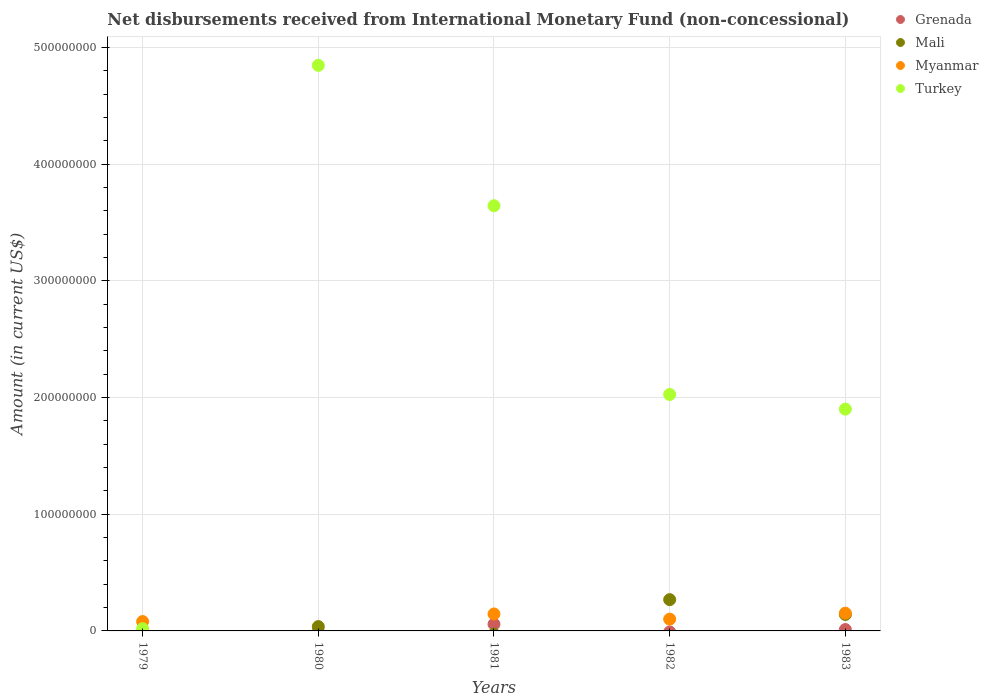What is the amount of disbursements received from International Monetary Fund in Myanmar in 1981?
Ensure brevity in your answer.  1.45e+07. Across all years, what is the maximum amount of disbursements received from International Monetary Fund in Grenada?
Your answer should be very brief. 5.80e+06. Across all years, what is the minimum amount of disbursements received from International Monetary Fund in Mali?
Provide a short and direct response. 0. In which year was the amount of disbursements received from International Monetary Fund in Turkey maximum?
Provide a short and direct response. 1980. What is the total amount of disbursements received from International Monetary Fund in Grenada in the graph?
Your answer should be very brief. 6.98e+06. What is the difference between the amount of disbursements received from International Monetary Fund in Mali in 1982 and that in 1983?
Give a very brief answer. 1.27e+07. What is the difference between the amount of disbursements received from International Monetary Fund in Grenada in 1979 and the amount of disbursements received from International Monetary Fund in Turkey in 1981?
Provide a short and direct response. -3.64e+08. What is the average amount of disbursements received from International Monetary Fund in Mali per year?
Your response must be concise. 8.92e+06. In the year 1982, what is the difference between the amount of disbursements received from International Monetary Fund in Mali and amount of disbursements received from International Monetary Fund in Myanmar?
Your response must be concise. 1.67e+07. In how many years, is the amount of disbursements received from International Monetary Fund in Grenada greater than 100000000 US$?
Your answer should be compact. 0. What is the ratio of the amount of disbursements received from International Monetary Fund in Myanmar in 1979 to that in 1982?
Offer a terse response. 0.8. Is the amount of disbursements received from International Monetary Fund in Myanmar in 1981 less than that in 1983?
Ensure brevity in your answer.  Yes. What is the difference between the highest and the second highest amount of disbursements received from International Monetary Fund in Turkey?
Your response must be concise. 1.20e+08. What is the difference between the highest and the lowest amount of disbursements received from International Monetary Fund in Mali?
Your answer should be very brief. 2.68e+07. In how many years, is the amount of disbursements received from International Monetary Fund in Grenada greater than the average amount of disbursements received from International Monetary Fund in Grenada taken over all years?
Offer a very short reply. 1. Is the sum of the amount of disbursements received from International Monetary Fund in Mali in 1980 and 1983 greater than the maximum amount of disbursements received from International Monetary Fund in Turkey across all years?
Give a very brief answer. No. Is it the case that in every year, the sum of the amount of disbursements received from International Monetary Fund in Mali and amount of disbursements received from International Monetary Fund in Turkey  is greater than the amount of disbursements received from International Monetary Fund in Myanmar?
Provide a succinct answer. No. Does the amount of disbursements received from International Monetary Fund in Grenada monotonically increase over the years?
Ensure brevity in your answer.  No. Is the amount of disbursements received from International Monetary Fund in Mali strictly greater than the amount of disbursements received from International Monetary Fund in Turkey over the years?
Your answer should be very brief. No. Is the amount of disbursements received from International Monetary Fund in Turkey strictly less than the amount of disbursements received from International Monetary Fund in Myanmar over the years?
Provide a succinct answer. No. How many years are there in the graph?
Your answer should be compact. 5. Does the graph contain grids?
Offer a very short reply. Yes. Where does the legend appear in the graph?
Ensure brevity in your answer.  Top right. How many legend labels are there?
Provide a succinct answer. 4. What is the title of the graph?
Ensure brevity in your answer.  Net disbursements received from International Monetary Fund (non-concessional). Does "Isle of Man" appear as one of the legend labels in the graph?
Provide a succinct answer. No. What is the Amount (in current US$) of Mali in 1979?
Provide a short and direct response. 0. What is the Amount (in current US$) of Myanmar in 1979?
Keep it short and to the point. 8.03e+06. What is the Amount (in current US$) of Turkey in 1979?
Your answer should be compact. 1.91e+06. What is the Amount (in current US$) in Mali in 1980?
Your answer should be compact. 3.70e+06. What is the Amount (in current US$) in Turkey in 1980?
Your response must be concise. 4.85e+08. What is the Amount (in current US$) of Grenada in 1981?
Provide a short and direct response. 5.80e+06. What is the Amount (in current US$) of Mali in 1981?
Offer a very short reply. 0. What is the Amount (in current US$) in Myanmar in 1981?
Provide a succinct answer. 1.45e+07. What is the Amount (in current US$) of Turkey in 1981?
Your answer should be very brief. 3.64e+08. What is the Amount (in current US$) of Mali in 1982?
Your answer should be very brief. 2.68e+07. What is the Amount (in current US$) of Myanmar in 1982?
Offer a terse response. 1.01e+07. What is the Amount (in current US$) in Turkey in 1982?
Make the answer very short. 2.03e+08. What is the Amount (in current US$) in Grenada in 1983?
Your response must be concise. 1.18e+06. What is the Amount (in current US$) of Mali in 1983?
Provide a succinct answer. 1.41e+07. What is the Amount (in current US$) in Myanmar in 1983?
Your response must be concise. 1.52e+07. What is the Amount (in current US$) of Turkey in 1983?
Give a very brief answer. 1.90e+08. Across all years, what is the maximum Amount (in current US$) of Grenada?
Keep it short and to the point. 5.80e+06. Across all years, what is the maximum Amount (in current US$) of Mali?
Ensure brevity in your answer.  2.68e+07. Across all years, what is the maximum Amount (in current US$) in Myanmar?
Offer a very short reply. 1.52e+07. Across all years, what is the maximum Amount (in current US$) in Turkey?
Offer a terse response. 4.85e+08. Across all years, what is the minimum Amount (in current US$) in Grenada?
Give a very brief answer. 0. Across all years, what is the minimum Amount (in current US$) in Turkey?
Keep it short and to the point. 1.91e+06. What is the total Amount (in current US$) in Grenada in the graph?
Ensure brevity in your answer.  6.98e+06. What is the total Amount (in current US$) of Mali in the graph?
Provide a short and direct response. 4.46e+07. What is the total Amount (in current US$) of Myanmar in the graph?
Provide a succinct answer. 4.79e+07. What is the total Amount (in current US$) of Turkey in the graph?
Your answer should be very brief. 1.24e+09. What is the difference between the Amount (in current US$) of Turkey in 1979 and that in 1980?
Your answer should be very brief. -4.83e+08. What is the difference between the Amount (in current US$) of Myanmar in 1979 and that in 1981?
Your answer should be very brief. -6.50e+06. What is the difference between the Amount (in current US$) in Turkey in 1979 and that in 1981?
Keep it short and to the point. -3.62e+08. What is the difference between the Amount (in current US$) of Myanmar in 1979 and that in 1982?
Your answer should be compact. -2.06e+06. What is the difference between the Amount (in current US$) of Turkey in 1979 and that in 1982?
Your answer should be compact. -2.01e+08. What is the difference between the Amount (in current US$) of Myanmar in 1979 and that in 1983?
Ensure brevity in your answer.  -7.18e+06. What is the difference between the Amount (in current US$) of Turkey in 1979 and that in 1983?
Your response must be concise. -1.88e+08. What is the difference between the Amount (in current US$) of Turkey in 1980 and that in 1981?
Provide a short and direct response. 1.20e+08. What is the difference between the Amount (in current US$) of Mali in 1980 and that in 1982?
Keep it short and to the point. -2.31e+07. What is the difference between the Amount (in current US$) in Turkey in 1980 and that in 1982?
Offer a very short reply. 2.82e+08. What is the difference between the Amount (in current US$) in Mali in 1980 and that in 1983?
Keep it short and to the point. -1.04e+07. What is the difference between the Amount (in current US$) of Turkey in 1980 and that in 1983?
Ensure brevity in your answer.  2.95e+08. What is the difference between the Amount (in current US$) of Myanmar in 1981 and that in 1982?
Your answer should be compact. 4.44e+06. What is the difference between the Amount (in current US$) of Turkey in 1981 and that in 1982?
Ensure brevity in your answer.  1.62e+08. What is the difference between the Amount (in current US$) of Grenada in 1981 and that in 1983?
Ensure brevity in your answer.  4.62e+06. What is the difference between the Amount (in current US$) of Myanmar in 1981 and that in 1983?
Offer a very short reply. -6.83e+05. What is the difference between the Amount (in current US$) of Turkey in 1981 and that in 1983?
Offer a terse response. 1.74e+08. What is the difference between the Amount (in current US$) of Mali in 1982 and that in 1983?
Offer a very short reply. 1.27e+07. What is the difference between the Amount (in current US$) of Myanmar in 1982 and that in 1983?
Give a very brief answer. -5.12e+06. What is the difference between the Amount (in current US$) in Turkey in 1982 and that in 1983?
Your response must be concise. 1.25e+07. What is the difference between the Amount (in current US$) of Myanmar in 1979 and the Amount (in current US$) of Turkey in 1980?
Make the answer very short. -4.77e+08. What is the difference between the Amount (in current US$) in Myanmar in 1979 and the Amount (in current US$) in Turkey in 1981?
Offer a terse response. -3.56e+08. What is the difference between the Amount (in current US$) in Myanmar in 1979 and the Amount (in current US$) in Turkey in 1982?
Provide a succinct answer. -1.95e+08. What is the difference between the Amount (in current US$) in Myanmar in 1979 and the Amount (in current US$) in Turkey in 1983?
Provide a short and direct response. -1.82e+08. What is the difference between the Amount (in current US$) of Mali in 1980 and the Amount (in current US$) of Myanmar in 1981?
Give a very brief answer. -1.08e+07. What is the difference between the Amount (in current US$) of Mali in 1980 and the Amount (in current US$) of Turkey in 1981?
Your answer should be very brief. -3.61e+08. What is the difference between the Amount (in current US$) in Mali in 1980 and the Amount (in current US$) in Myanmar in 1982?
Your response must be concise. -6.39e+06. What is the difference between the Amount (in current US$) in Mali in 1980 and the Amount (in current US$) in Turkey in 1982?
Ensure brevity in your answer.  -1.99e+08. What is the difference between the Amount (in current US$) in Mali in 1980 and the Amount (in current US$) in Myanmar in 1983?
Make the answer very short. -1.15e+07. What is the difference between the Amount (in current US$) in Mali in 1980 and the Amount (in current US$) in Turkey in 1983?
Your answer should be very brief. -1.86e+08. What is the difference between the Amount (in current US$) of Grenada in 1981 and the Amount (in current US$) of Mali in 1982?
Keep it short and to the point. -2.10e+07. What is the difference between the Amount (in current US$) in Grenada in 1981 and the Amount (in current US$) in Myanmar in 1982?
Your answer should be very brief. -4.29e+06. What is the difference between the Amount (in current US$) of Grenada in 1981 and the Amount (in current US$) of Turkey in 1982?
Keep it short and to the point. -1.97e+08. What is the difference between the Amount (in current US$) of Myanmar in 1981 and the Amount (in current US$) of Turkey in 1982?
Your answer should be compact. -1.88e+08. What is the difference between the Amount (in current US$) in Grenada in 1981 and the Amount (in current US$) in Mali in 1983?
Ensure brevity in your answer.  -8.30e+06. What is the difference between the Amount (in current US$) of Grenada in 1981 and the Amount (in current US$) of Myanmar in 1983?
Offer a terse response. -9.41e+06. What is the difference between the Amount (in current US$) of Grenada in 1981 and the Amount (in current US$) of Turkey in 1983?
Give a very brief answer. -1.84e+08. What is the difference between the Amount (in current US$) in Myanmar in 1981 and the Amount (in current US$) in Turkey in 1983?
Give a very brief answer. -1.76e+08. What is the difference between the Amount (in current US$) of Mali in 1982 and the Amount (in current US$) of Myanmar in 1983?
Offer a terse response. 1.16e+07. What is the difference between the Amount (in current US$) of Mali in 1982 and the Amount (in current US$) of Turkey in 1983?
Give a very brief answer. -1.63e+08. What is the difference between the Amount (in current US$) of Myanmar in 1982 and the Amount (in current US$) of Turkey in 1983?
Ensure brevity in your answer.  -1.80e+08. What is the average Amount (in current US$) in Grenada per year?
Offer a terse response. 1.40e+06. What is the average Amount (in current US$) of Mali per year?
Make the answer very short. 8.92e+06. What is the average Amount (in current US$) of Myanmar per year?
Offer a terse response. 9.57e+06. What is the average Amount (in current US$) in Turkey per year?
Your answer should be very brief. 2.49e+08. In the year 1979, what is the difference between the Amount (in current US$) in Myanmar and Amount (in current US$) in Turkey?
Give a very brief answer. 6.12e+06. In the year 1980, what is the difference between the Amount (in current US$) of Mali and Amount (in current US$) of Turkey?
Your answer should be very brief. -4.81e+08. In the year 1981, what is the difference between the Amount (in current US$) in Grenada and Amount (in current US$) in Myanmar?
Offer a very short reply. -8.73e+06. In the year 1981, what is the difference between the Amount (in current US$) in Grenada and Amount (in current US$) in Turkey?
Your answer should be compact. -3.59e+08. In the year 1981, what is the difference between the Amount (in current US$) of Myanmar and Amount (in current US$) of Turkey?
Offer a terse response. -3.50e+08. In the year 1982, what is the difference between the Amount (in current US$) of Mali and Amount (in current US$) of Myanmar?
Provide a short and direct response. 1.67e+07. In the year 1982, what is the difference between the Amount (in current US$) in Mali and Amount (in current US$) in Turkey?
Provide a succinct answer. -1.76e+08. In the year 1982, what is the difference between the Amount (in current US$) of Myanmar and Amount (in current US$) of Turkey?
Your answer should be very brief. -1.93e+08. In the year 1983, what is the difference between the Amount (in current US$) of Grenada and Amount (in current US$) of Mali?
Your response must be concise. -1.29e+07. In the year 1983, what is the difference between the Amount (in current US$) in Grenada and Amount (in current US$) in Myanmar?
Provide a short and direct response. -1.40e+07. In the year 1983, what is the difference between the Amount (in current US$) in Grenada and Amount (in current US$) in Turkey?
Your response must be concise. -1.89e+08. In the year 1983, what is the difference between the Amount (in current US$) in Mali and Amount (in current US$) in Myanmar?
Your response must be concise. -1.11e+06. In the year 1983, what is the difference between the Amount (in current US$) of Mali and Amount (in current US$) of Turkey?
Ensure brevity in your answer.  -1.76e+08. In the year 1983, what is the difference between the Amount (in current US$) in Myanmar and Amount (in current US$) in Turkey?
Your response must be concise. -1.75e+08. What is the ratio of the Amount (in current US$) in Turkey in 1979 to that in 1980?
Offer a terse response. 0. What is the ratio of the Amount (in current US$) in Myanmar in 1979 to that in 1981?
Your response must be concise. 0.55. What is the ratio of the Amount (in current US$) in Turkey in 1979 to that in 1981?
Your response must be concise. 0.01. What is the ratio of the Amount (in current US$) of Myanmar in 1979 to that in 1982?
Offer a terse response. 0.8. What is the ratio of the Amount (in current US$) of Turkey in 1979 to that in 1982?
Offer a terse response. 0.01. What is the ratio of the Amount (in current US$) of Myanmar in 1979 to that in 1983?
Offer a very short reply. 0.53. What is the ratio of the Amount (in current US$) of Turkey in 1979 to that in 1983?
Provide a succinct answer. 0.01. What is the ratio of the Amount (in current US$) of Turkey in 1980 to that in 1981?
Your answer should be compact. 1.33. What is the ratio of the Amount (in current US$) in Mali in 1980 to that in 1982?
Ensure brevity in your answer.  0.14. What is the ratio of the Amount (in current US$) in Turkey in 1980 to that in 1982?
Provide a succinct answer. 2.39. What is the ratio of the Amount (in current US$) in Mali in 1980 to that in 1983?
Your answer should be compact. 0.26. What is the ratio of the Amount (in current US$) in Turkey in 1980 to that in 1983?
Your answer should be very brief. 2.55. What is the ratio of the Amount (in current US$) of Myanmar in 1981 to that in 1982?
Your answer should be compact. 1.44. What is the ratio of the Amount (in current US$) in Turkey in 1981 to that in 1982?
Give a very brief answer. 1.8. What is the ratio of the Amount (in current US$) in Grenada in 1981 to that in 1983?
Give a very brief answer. 4.92. What is the ratio of the Amount (in current US$) in Myanmar in 1981 to that in 1983?
Give a very brief answer. 0.96. What is the ratio of the Amount (in current US$) in Turkey in 1981 to that in 1983?
Your answer should be compact. 1.92. What is the ratio of the Amount (in current US$) in Mali in 1982 to that in 1983?
Provide a short and direct response. 1.9. What is the ratio of the Amount (in current US$) of Myanmar in 1982 to that in 1983?
Give a very brief answer. 0.66. What is the ratio of the Amount (in current US$) in Turkey in 1982 to that in 1983?
Provide a succinct answer. 1.07. What is the difference between the highest and the second highest Amount (in current US$) of Mali?
Offer a very short reply. 1.27e+07. What is the difference between the highest and the second highest Amount (in current US$) of Myanmar?
Your response must be concise. 6.83e+05. What is the difference between the highest and the second highest Amount (in current US$) of Turkey?
Your answer should be compact. 1.20e+08. What is the difference between the highest and the lowest Amount (in current US$) of Grenada?
Your answer should be compact. 5.80e+06. What is the difference between the highest and the lowest Amount (in current US$) of Mali?
Provide a succinct answer. 2.68e+07. What is the difference between the highest and the lowest Amount (in current US$) in Myanmar?
Make the answer very short. 1.52e+07. What is the difference between the highest and the lowest Amount (in current US$) in Turkey?
Provide a short and direct response. 4.83e+08. 